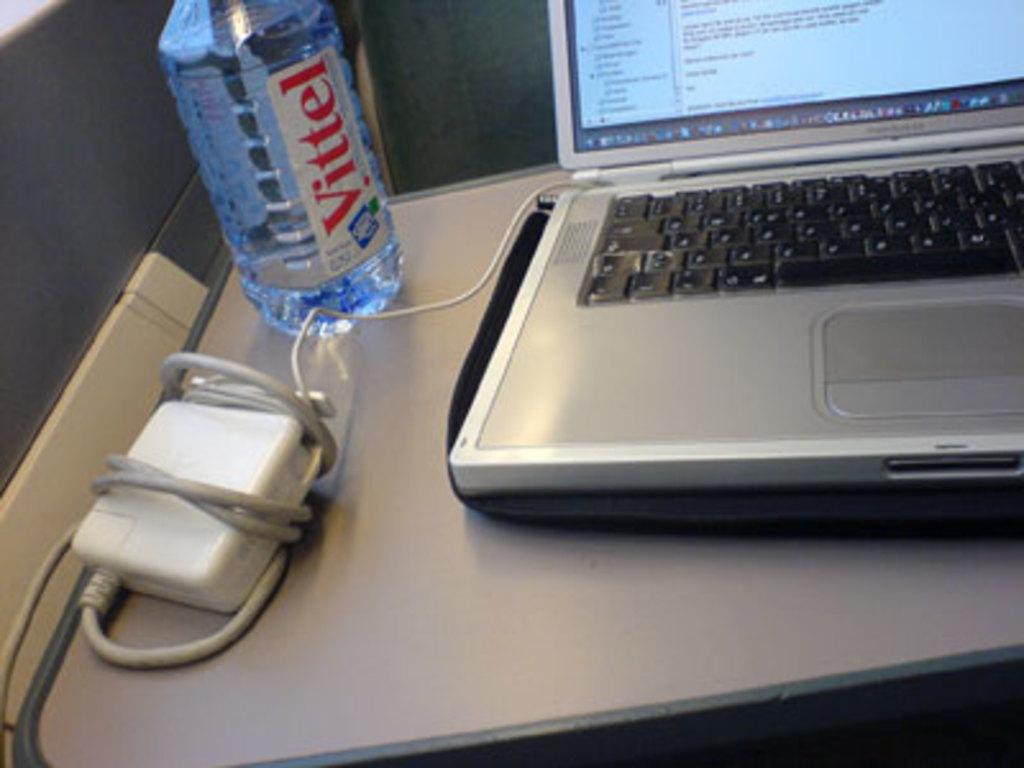What brand of water is shown?
Offer a very short reply. Vittel. 